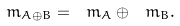Convert formula to latex. <formula><loc_0><loc_0><loc_500><loc_500>\ m _ { A \oplus B } = \ m _ { A } \oplus \ m _ { B } .</formula> 